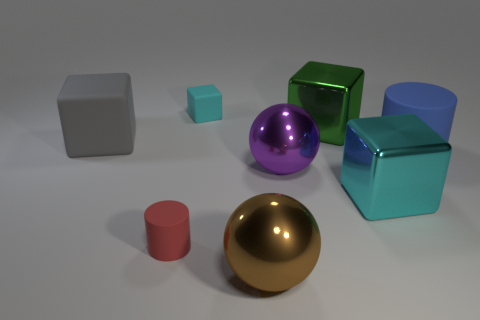There is a gray rubber object that is the same shape as the green shiny object; what size is it?
Offer a terse response. Large. There is a cyan metal thing; does it have the same shape as the large shiny thing that is in front of the big cyan shiny cube?
Offer a terse response. No. What size is the purple object in front of the big matte object that is right of the big cyan shiny object?
Provide a succinct answer. Large. Is the number of big rubber cubes that are right of the big cyan shiny thing the same as the number of small red matte cylinders that are on the right side of the cyan matte thing?
Give a very brief answer. Yes. The other shiny object that is the same shape as the green metallic object is what color?
Your answer should be compact. Cyan. What number of other matte cubes are the same color as the tiny rubber cube?
Provide a short and direct response. 0. Does the large object in front of the small red thing have the same shape as the purple shiny object?
Give a very brief answer. Yes. What is the shape of the shiny thing that is left of the large ball that is behind the metal cube that is in front of the big rubber cylinder?
Offer a very short reply. Sphere. How big is the gray matte block?
Offer a very short reply. Large. There is a tiny cube that is made of the same material as the gray thing; what is its color?
Ensure brevity in your answer.  Cyan. 